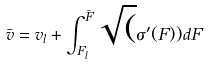Convert formula to latex. <formula><loc_0><loc_0><loc_500><loc_500>\bar { v } = v _ { l } + \int _ { F _ { l } } ^ { \bar { F } } \sqrt { ( } \sigma ^ { \prime } ( F ) ) d F</formula> 